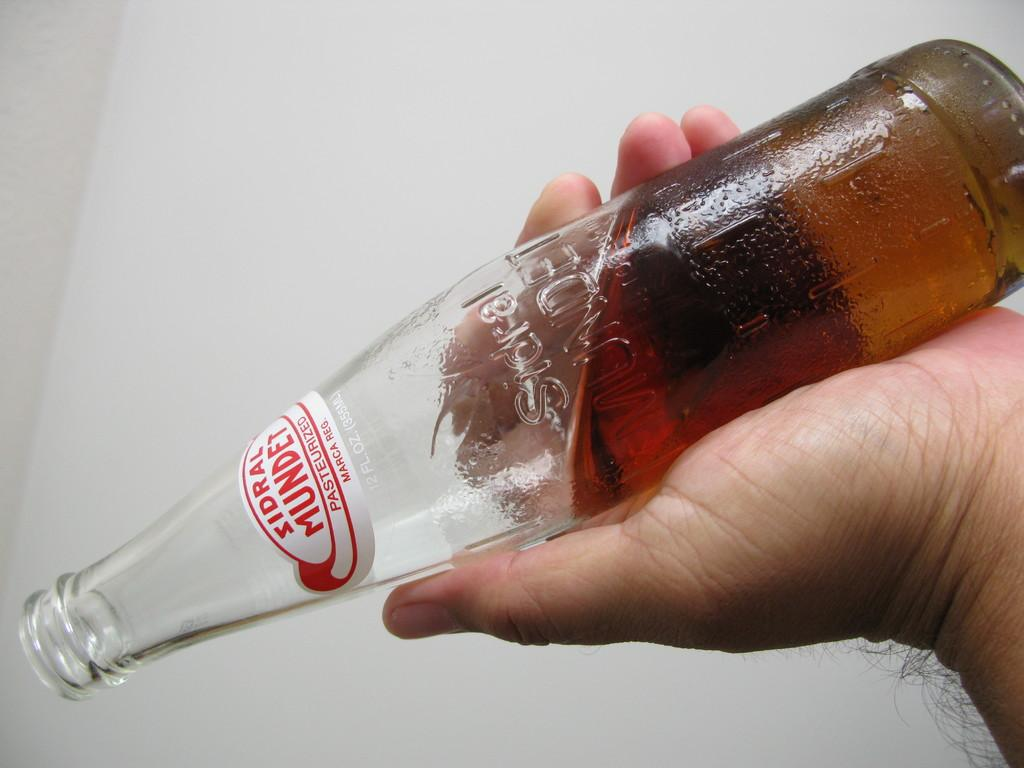<image>
Summarize the visual content of the image. A hand holds a half bottle of sidral mundet 